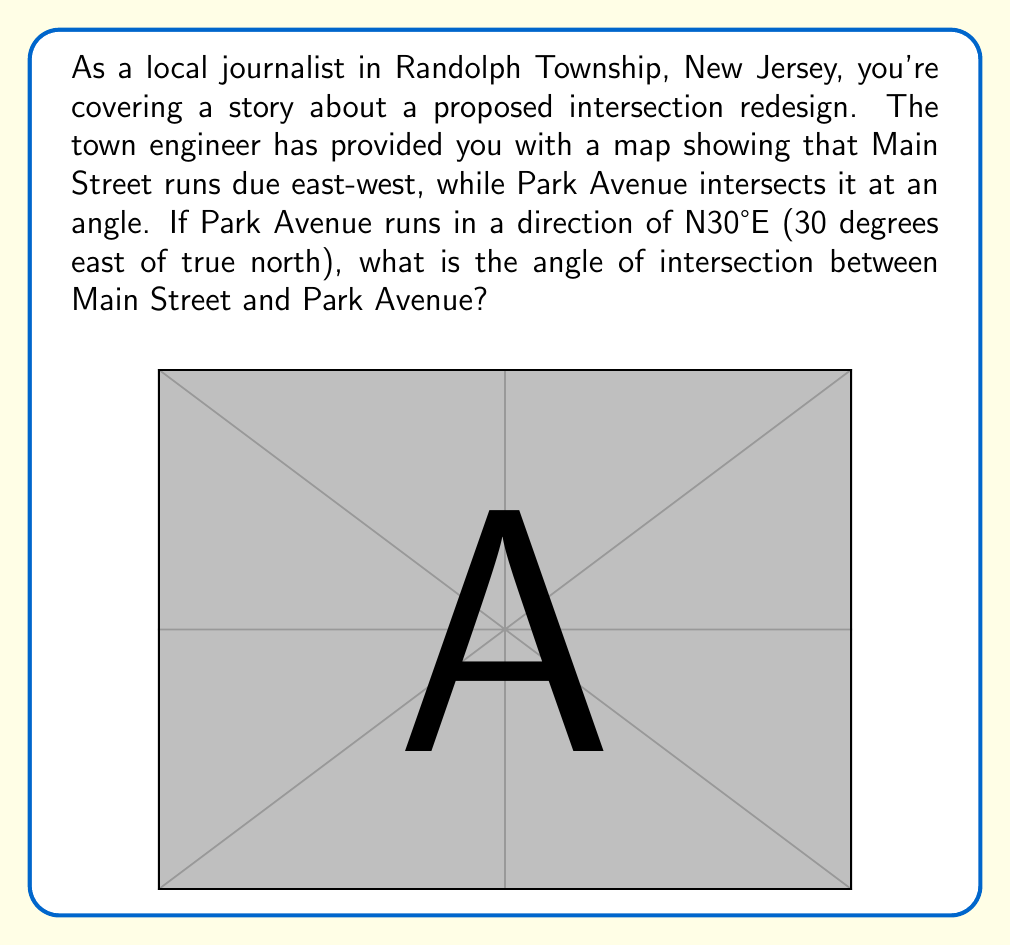Solve this math problem. To solve this problem, we need to understand the relationship between the directions of the two streets:

1) Main Street runs east-west, which means it forms a 90° angle with true north.

2) Park Avenue runs N30°E, which means it forms a 30° angle with true north.

3) The angle of intersection between the two streets is the difference between their angles relative to north:

   $$ \text{Intersection Angle} = 90° - 30° = 60° $$

4) We can also think about this in terms of complementary angles:
   - The complement of 30° is 60° (90° - 30° = 60°)
   - Park Avenue makes a 30° angle with north, so it must make a 60° angle with east

5) Since Main Street runs east-west, it aligns with the east direction. Therefore, the angle between Park Avenue and Main Street is indeed 60°.

This result can be verified using the properties of parallel lines and transversals. The north-south line would be parallel to the west-east line, and Park Avenue acts as a transversal, creating corresponding angles.
Answer: The angle of intersection between Main Street and Park Avenue is 60°. 